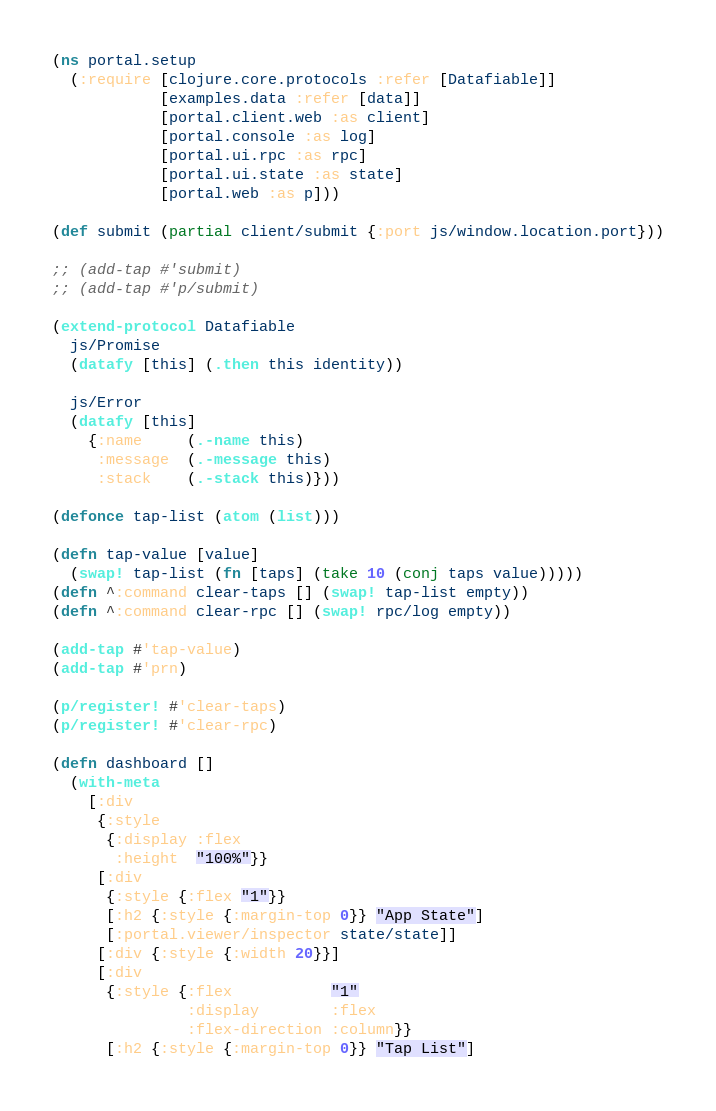<code> <loc_0><loc_0><loc_500><loc_500><_Clojure_>(ns portal.setup
  (:require [clojure.core.protocols :refer [Datafiable]]
            [examples.data :refer [data]]
            [portal.client.web :as client]
            [portal.console :as log]
            [portal.ui.rpc :as rpc]
            [portal.ui.state :as state]
            [portal.web :as p]))

(def submit (partial client/submit {:port js/window.location.port}))

;; (add-tap #'submit)
;; (add-tap #'p/submit)

(extend-protocol Datafiable
  js/Promise
  (datafy [this] (.then this identity))

  js/Error
  (datafy [this]
    {:name     (.-name this)
     :message  (.-message this)
     :stack    (.-stack this)}))

(defonce tap-list (atom (list)))

(defn tap-value [value]
  (swap! tap-list (fn [taps] (take 10 (conj taps value)))))
(defn ^:command clear-taps [] (swap! tap-list empty))
(defn ^:command clear-rpc [] (swap! rpc/log empty))

(add-tap #'tap-value)
(add-tap #'prn)

(p/register! #'clear-taps)
(p/register! #'clear-rpc)

(defn dashboard []
  (with-meta
    [:div
     {:style
      {:display :flex
       :height  "100%"}}
     [:div
      {:style {:flex "1"}}
      [:h2 {:style {:margin-top 0}} "App State"]
      [:portal.viewer/inspector state/state]]
     [:div {:style {:width 20}}]
     [:div
      {:style {:flex           "1"
               :display        :flex
               :flex-direction :column}}
      [:h2 {:style {:margin-top 0}} "Tap List"]</code> 